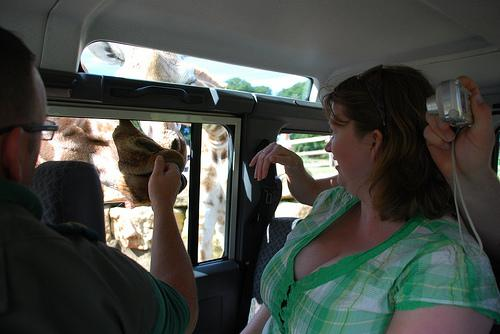Question: what color is woman's shirt?
Choices:
A. Green and white.
B. Pink and red.
C. Blue and Orange.
D. Purple and grey.
Answer with the letter. Answer: A Question: what is beside her head?
Choices:
A. Hand with camera.
B. Hand with fork.
C. Hand with clock.
D. Hand with shoe.
Answer with the letter. Answer: A Question: where is the cat?
Choices:
A. Under the bed.
B. In the pool.
C. No cat.
D. Sleeping on couch.
Answer with the letter. Answer: C Question: what is on the airplane?
Choices:
A. Orange stars.
B. No plane.
C. Purple stick figures.
D. Apple juice advertisement.
Answer with the letter. Answer: B Question: how many people are in green?
Choices:
A. Two.
B. Three.
C. One.
D. Zero.
Answer with the letter. Answer: C Question: who is wearing glasses?
Choices:
A. Man on left.
B. Tall woman.
C. Elderly lady.
D. Smiling girl.
Answer with the letter. Answer: A Question: when is it raining?
Choices:
A. All the time.
B. In the morning.
C. No rain.
D. Wednesday.
Answer with the letter. Answer: C 